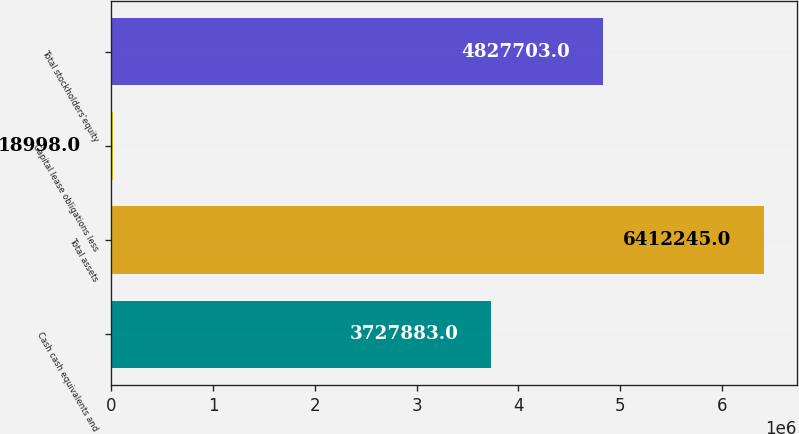Convert chart to OTSL. <chart><loc_0><loc_0><loc_500><loc_500><bar_chart><fcel>Cash cash equivalents and<fcel>Total assets<fcel>Capital lease obligations less<fcel>Total stockholders'equity<nl><fcel>3.72788e+06<fcel>6.41224e+06<fcel>18998<fcel>4.8277e+06<nl></chart> 